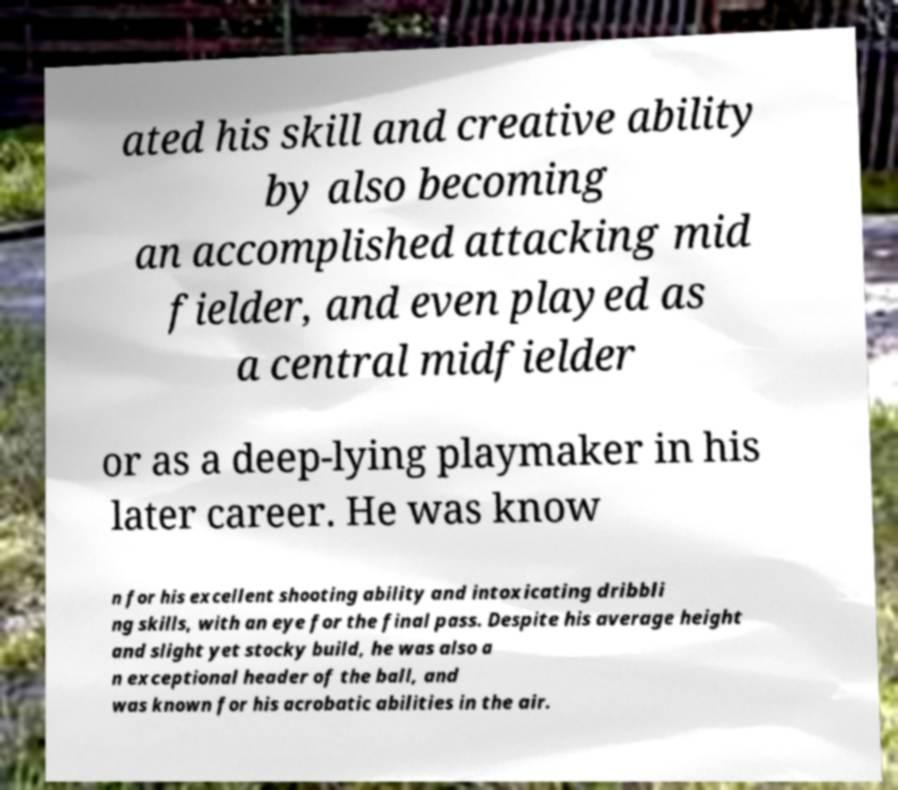Please read and relay the text visible in this image. What does it say? ated his skill and creative ability by also becoming an accomplished attacking mid fielder, and even played as a central midfielder or as a deep-lying playmaker in his later career. He was know n for his excellent shooting ability and intoxicating dribbli ng skills, with an eye for the final pass. Despite his average height and slight yet stocky build, he was also a n exceptional header of the ball, and was known for his acrobatic abilities in the air. 